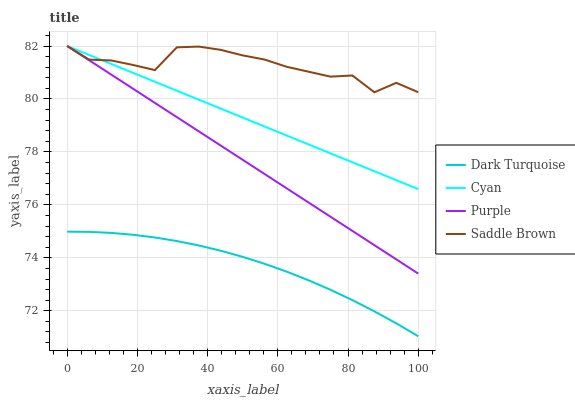Does Dark Turquoise have the minimum area under the curve?
Answer yes or no. Yes. Does Saddle Brown have the maximum area under the curve?
Answer yes or no. Yes. Does Saddle Brown have the minimum area under the curve?
Answer yes or no. No. Does Dark Turquoise have the maximum area under the curve?
Answer yes or no. No. Is Purple the smoothest?
Answer yes or no. Yes. Is Saddle Brown the roughest?
Answer yes or no. Yes. Is Dark Turquoise the smoothest?
Answer yes or no. No. Is Dark Turquoise the roughest?
Answer yes or no. No. Does Dark Turquoise have the lowest value?
Answer yes or no. Yes. Does Saddle Brown have the lowest value?
Answer yes or no. No. Does Cyan have the highest value?
Answer yes or no. Yes. Does Dark Turquoise have the highest value?
Answer yes or no. No. Is Dark Turquoise less than Saddle Brown?
Answer yes or no. Yes. Is Saddle Brown greater than Dark Turquoise?
Answer yes or no. Yes. Does Cyan intersect Saddle Brown?
Answer yes or no. Yes. Is Cyan less than Saddle Brown?
Answer yes or no. No. Is Cyan greater than Saddle Brown?
Answer yes or no. No. Does Dark Turquoise intersect Saddle Brown?
Answer yes or no. No. 